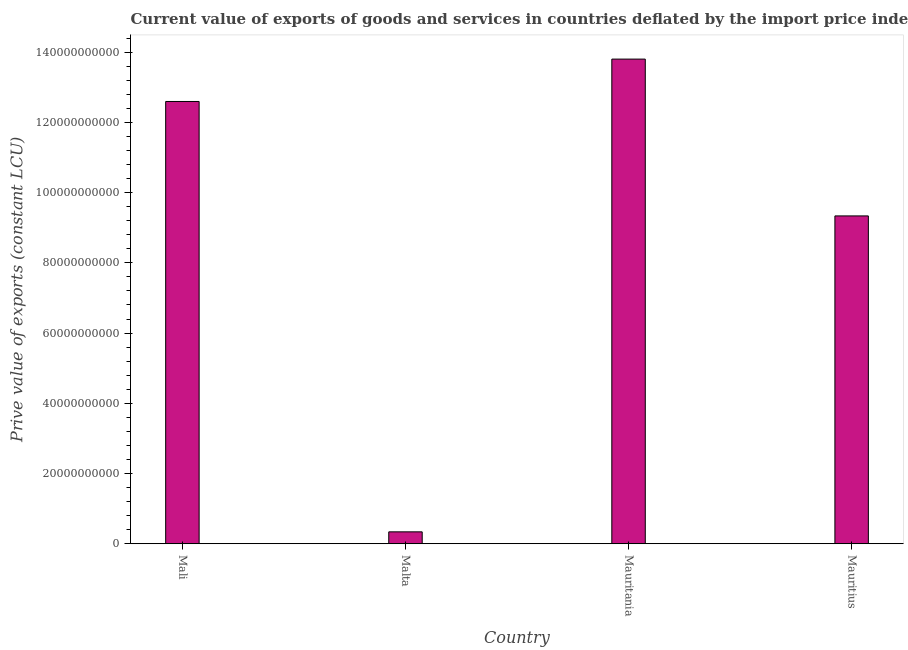Does the graph contain grids?
Offer a terse response. No. What is the title of the graph?
Your response must be concise. Current value of exports of goods and services in countries deflated by the import price index. What is the label or title of the Y-axis?
Make the answer very short. Prive value of exports (constant LCU). What is the price value of exports in Mali?
Make the answer very short. 1.26e+11. Across all countries, what is the maximum price value of exports?
Your answer should be very brief. 1.38e+11. Across all countries, what is the minimum price value of exports?
Provide a succinct answer. 3.39e+09. In which country was the price value of exports maximum?
Offer a terse response. Mauritania. In which country was the price value of exports minimum?
Your answer should be compact. Malta. What is the sum of the price value of exports?
Keep it short and to the point. 3.61e+11. What is the difference between the price value of exports in Mali and Mauritius?
Offer a terse response. 3.26e+1. What is the average price value of exports per country?
Make the answer very short. 9.02e+1. What is the median price value of exports?
Your answer should be very brief. 1.10e+11. In how many countries, is the price value of exports greater than 12000000000 LCU?
Ensure brevity in your answer.  3. What is the difference between the highest and the second highest price value of exports?
Your answer should be compact. 1.21e+1. What is the difference between the highest and the lowest price value of exports?
Make the answer very short. 1.35e+11. In how many countries, is the price value of exports greater than the average price value of exports taken over all countries?
Give a very brief answer. 3. What is the difference between two consecutive major ticks on the Y-axis?
Your answer should be compact. 2.00e+1. Are the values on the major ticks of Y-axis written in scientific E-notation?
Ensure brevity in your answer.  No. What is the Prive value of exports (constant LCU) in Mali?
Your answer should be very brief. 1.26e+11. What is the Prive value of exports (constant LCU) in Malta?
Provide a succinct answer. 3.39e+09. What is the Prive value of exports (constant LCU) in Mauritania?
Your answer should be compact. 1.38e+11. What is the Prive value of exports (constant LCU) of Mauritius?
Your answer should be very brief. 9.34e+1. What is the difference between the Prive value of exports (constant LCU) in Mali and Malta?
Your response must be concise. 1.23e+11. What is the difference between the Prive value of exports (constant LCU) in Mali and Mauritania?
Ensure brevity in your answer.  -1.21e+1. What is the difference between the Prive value of exports (constant LCU) in Mali and Mauritius?
Give a very brief answer. 3.26e+1. What is the difference between the Prive value of exports (constant LCU) in Malta and Mauritania?
Offer a very short reply. -1.35e+11. What is the difference between the Prive value of exports (constant LCU) in Malta and Mauritius?
Ensure brevity in your answer.  -9.00e+1. What is the difference between the Prive value of exports (constant LCU) in Mauritania and Mauritius?
Ensure brevity in your answer.  4.47e+1. What is the ratio of the Prive value of exports (constant LCU) in Mali to that in Malta?
Keep it short and to the point. 37.18. What is the ratio of the Prive value of exports (constant LCU) in Mali to that in Mauritius?
Ensure brevity in your answer.  1.35. What is the ratio of the Prive value of exports (constant LCU) in Malta to that in Mauritania?
Offer a very short reply. 0.03. What is the ratio of the Prive value of exports (constant LCU) in Malta to that in Mauritius?
Your answer should be very brief. 0.04. What is the ratio of the Prive value of exports (constant LCU) in Mauritania to that in Mauritius?
Your answer should be compact. 1.48. 